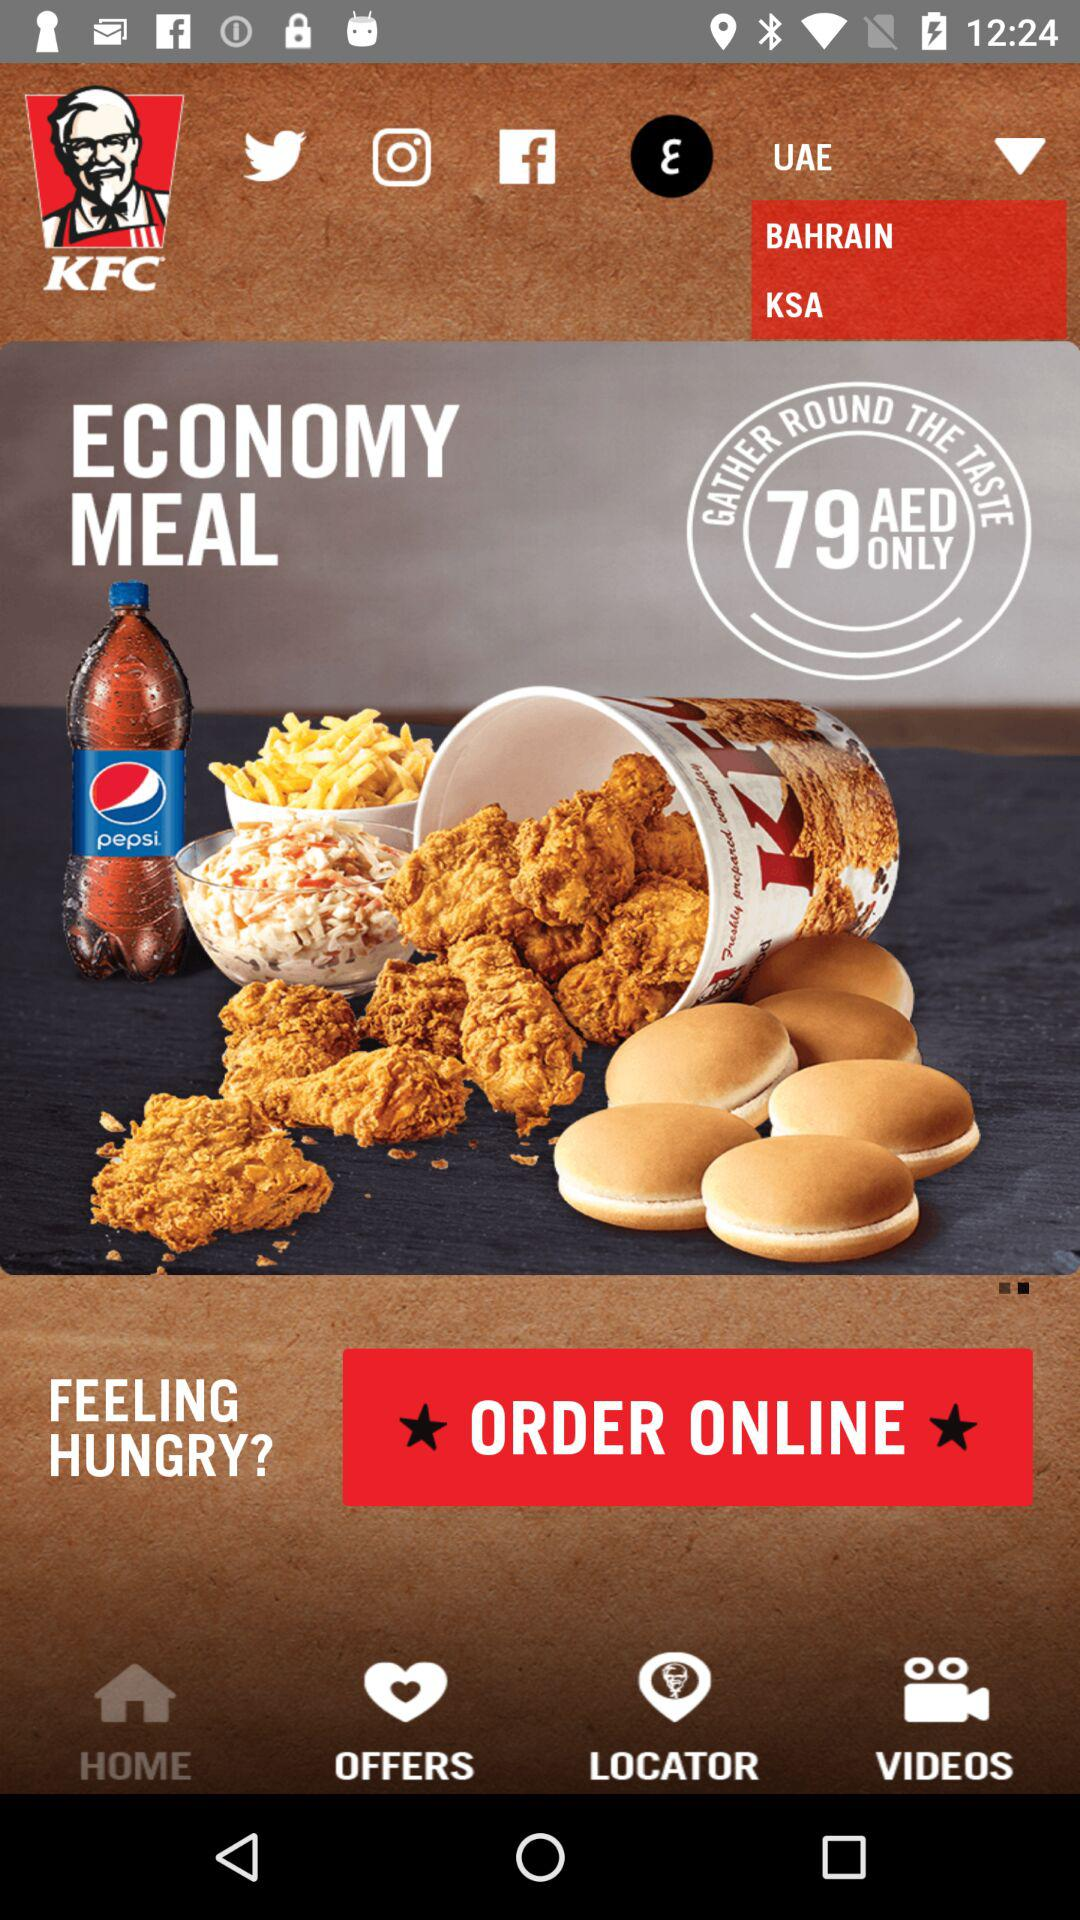What is the currency of the price? The currency of the price is AED. 